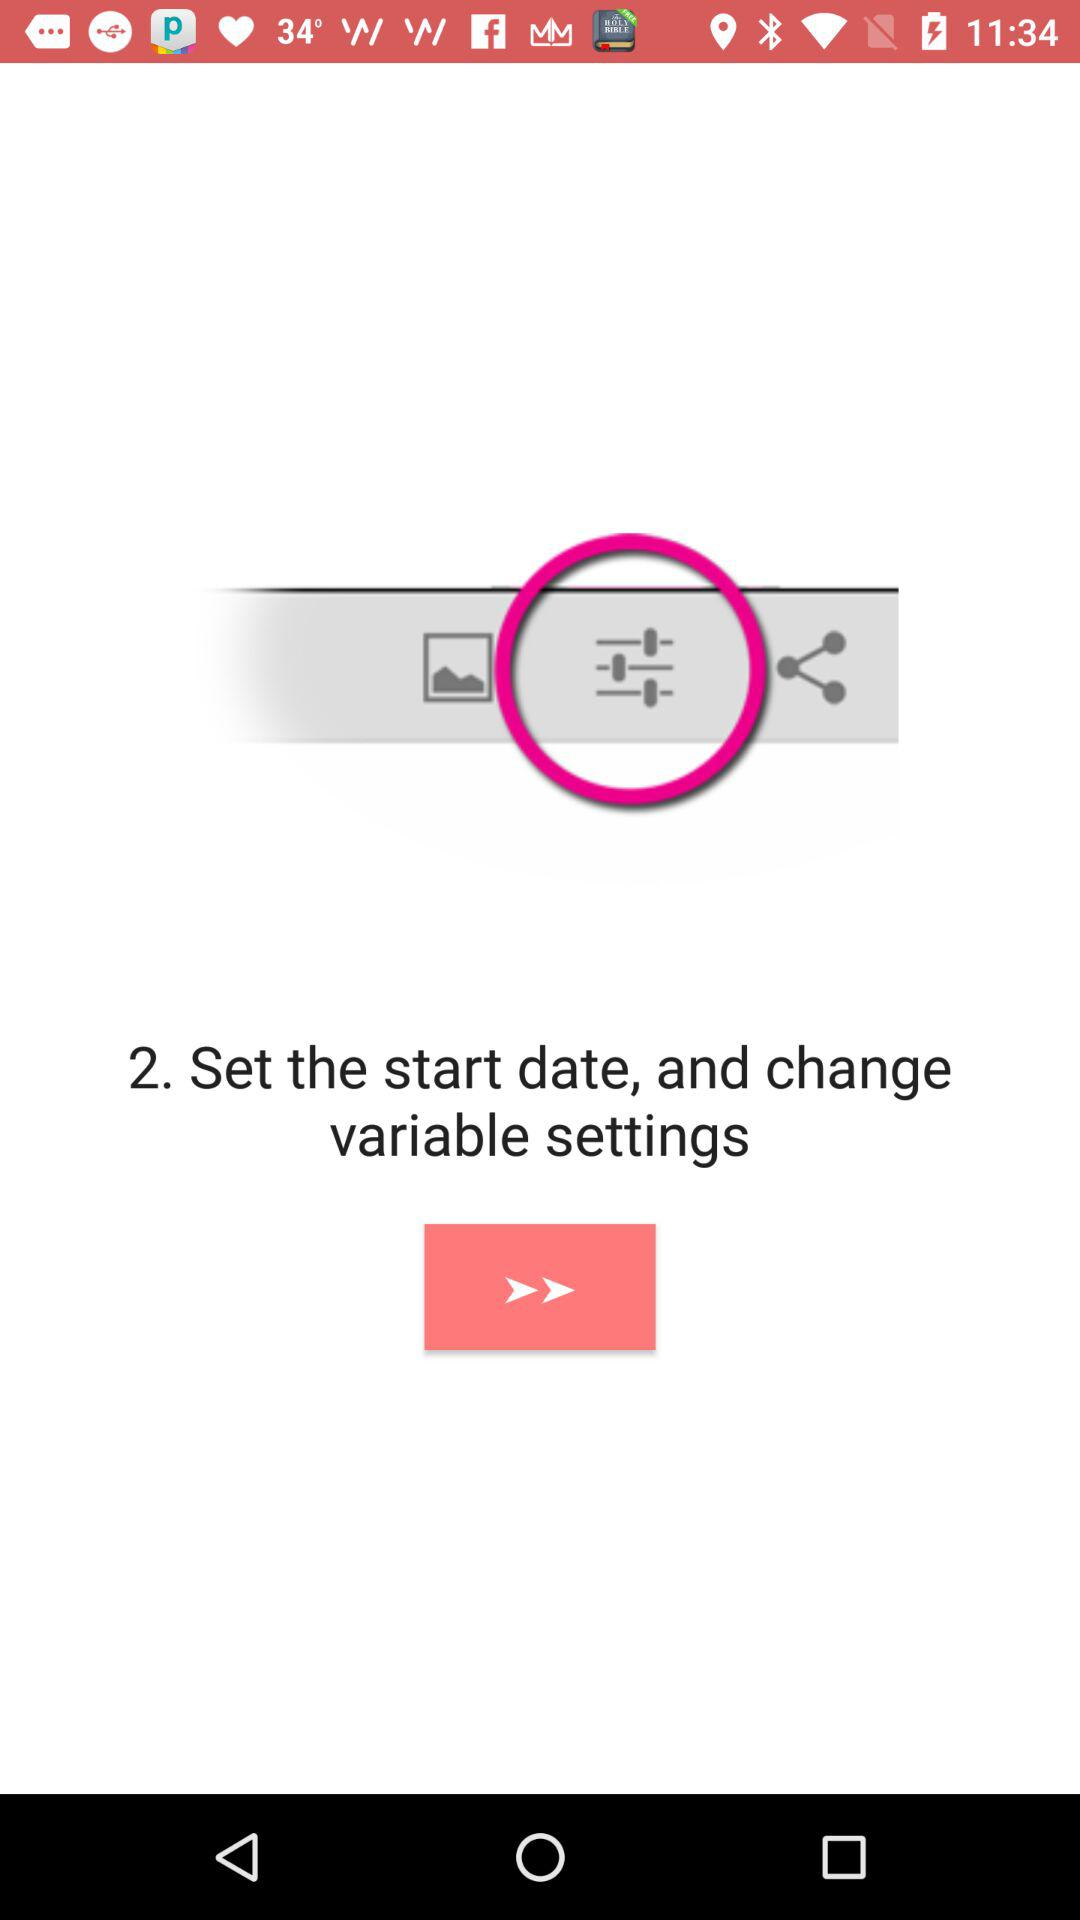What is step 2? Step 2 is "Set the start date, and change variable settings". 